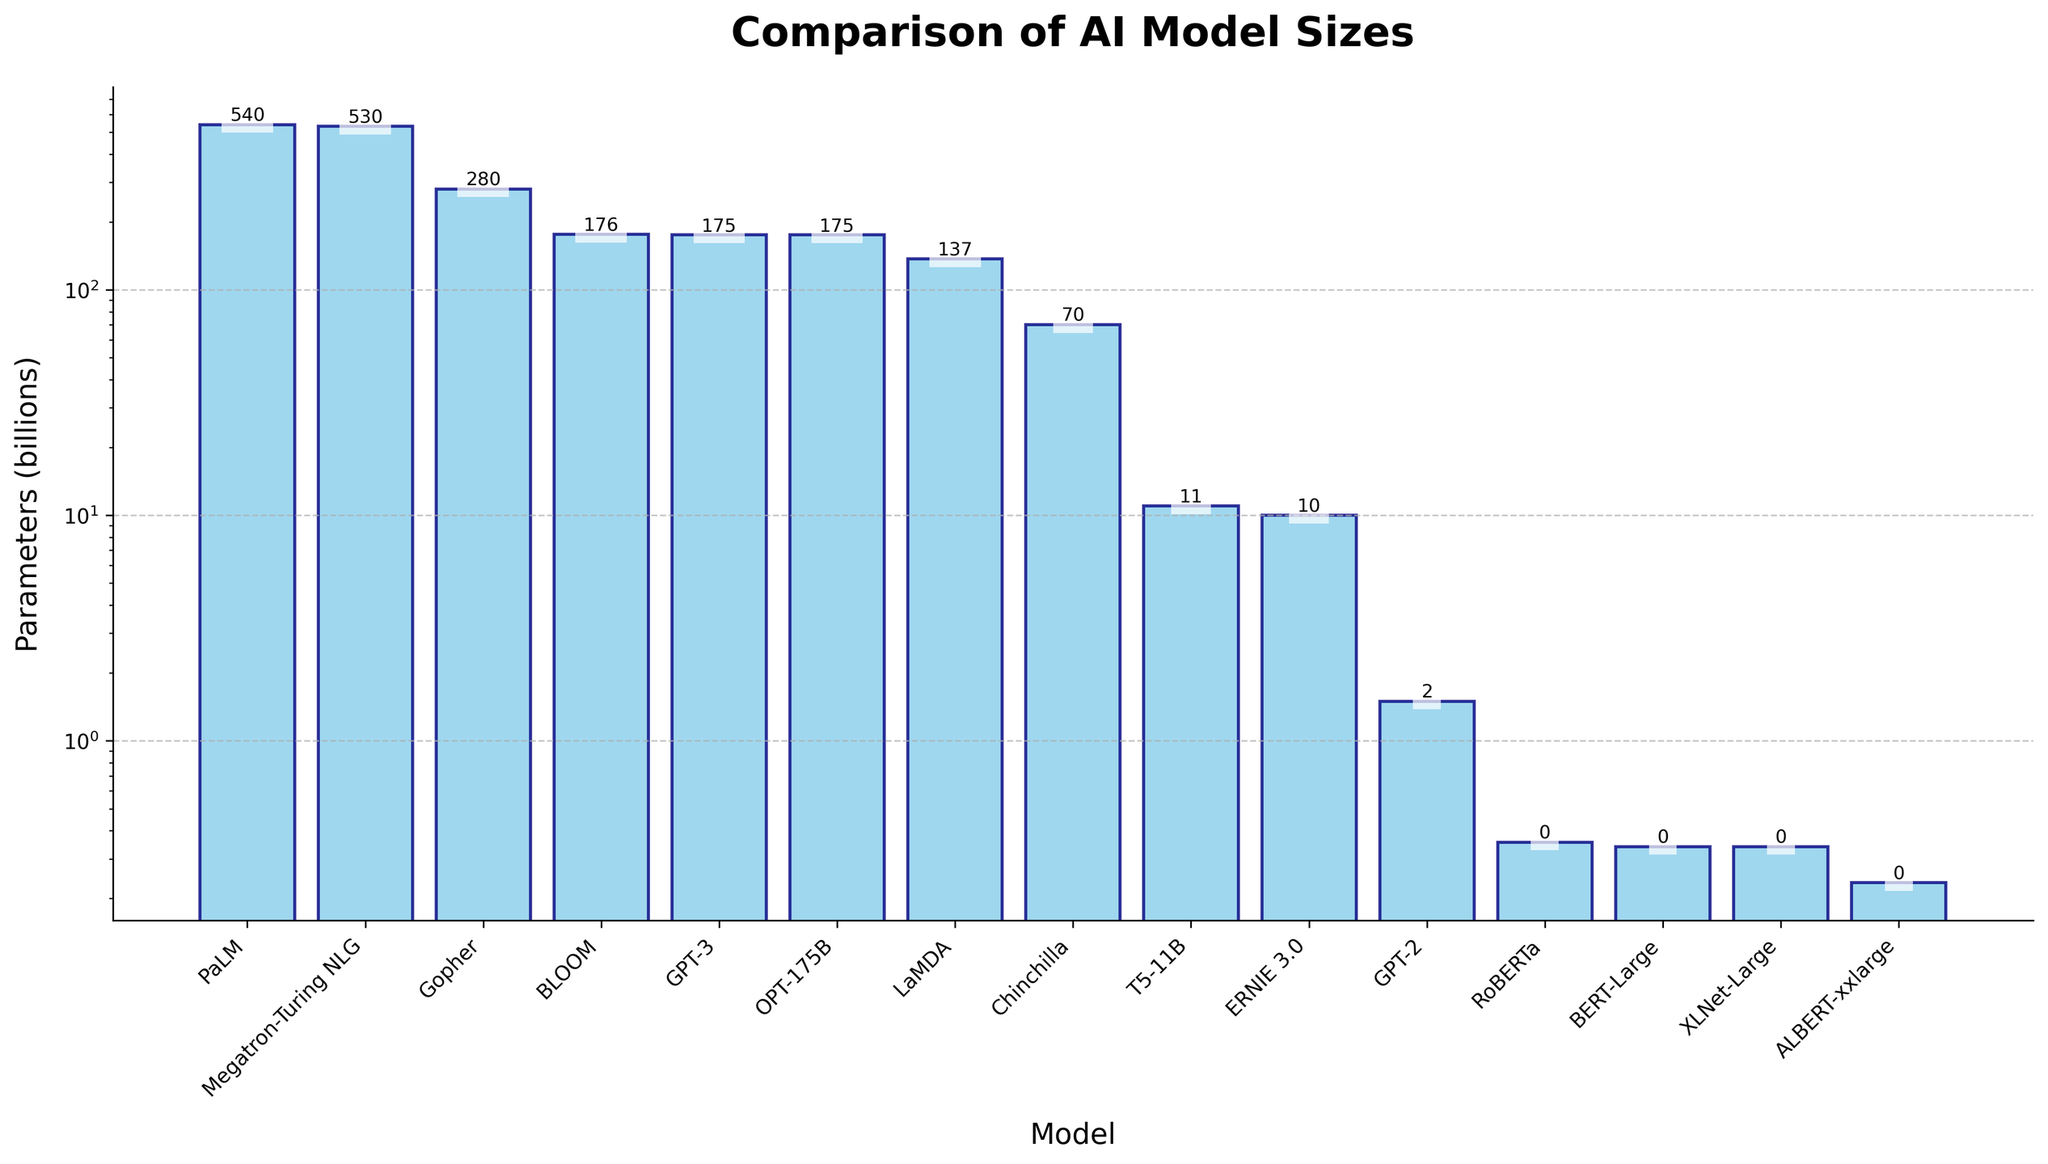What is the AI model with the smallest number of parameters? From the figure, the lowest bar represents the AI model with the smallest number of parameters. The smallest bar corresponds to "ALBERT-xxlarge" with 0.235 billion parameters.
Answer: ALBERT-xxlarge Which model has more parameters, GPT-3 or BERT-Large? Comparing the bars for GPT-3 and BERT-Large, GPT-3 has a height corresponding to 175 billion parameters whereas BERT-Large has a much smaller height corresponding to 0.34 billion parameters. Therefore, GPT-3 has more parameters.
Answer: GPT-3 How many models have more than 100 billion parameters? From the figure, we need to count the bars that exceed the 100 billion mark on the y-axis. The models are GPT-3, Megatron-Turing NLG, PaLM, LaMDA, BLOOM, OPT-175B, and Gopher, making a total of 7 models.
Answer: 7 What is the difference in the number of parameters between the largest and smallest models? The largest model (PaLM) has 540 billion parameters and the smallest model (ALBERT-xxlarge) has 0.235 billion parameters. The difference is 540 - 0.235 = 539.765 billion parameters.
Answer: 539.765 billion Which two models have the same number of parameters, and what is that number? By looking at the bar heights, GPT-3 and OPT-175B have bars of the same height, both representing 175 billion parameters.
Answer: GPT-3 and OPT-175B; 175 billion Find the average number of parameters for the models with less than 1 billion parameters. The models with less than 1 billion parameters are BERT-Large (0.34), RoBERTa (0.355), ALBERT-xxlarge (0.235), and XLNet-Large (0.34). The average is calculated as (0.34 + 0.355 + 0.235 + 0.34) / 4 = 0.3175 billion parameters.
Answer: 0.3175 billion What is the median number of parameters among all the models? To find the median, first, list all parameters in ascending order: 0.235, 0.34, 0.34, 0.355, 1.5, 10, 11, 70, 137, 175, 175, 176, 280, 530, 540. The median is the middle value, which is the 8th value in this ordered list: 70 billion parameters.
Answer: 70 billion Which model lies between ERNIE 3.0 and GPT-2 in terms of the number of parameters? ERNIE 3.0 has 10 billion parameters and GPT-2 has 1.5 billion parameters. In terms of model sizes in the figure, T5-11B with 11 billion parameters lies between them.
Answer: T5-11B If we sum the parameters of the top three largest models, what is the total number of parameters? The top three largest models are PaLM (540), Megatron-Turing NLG (530), and Gopher (280). Summing their parameters: 540 + 530 + 280 = 1350 billion parameters.
Answer: 1350 billion Which models have fewer parameters than GPT-2? GPT-2 has 1.5 billion parameters. The models with fewer parameters are BERT-Large (0.34), RoBERTa (0.355), ALBERT-xxlarge (0.235), and XLNet-Large (0.34).
Answer: BERT-Large, RoBERTa, ALBERT-xxlarge, XLNet-Large 